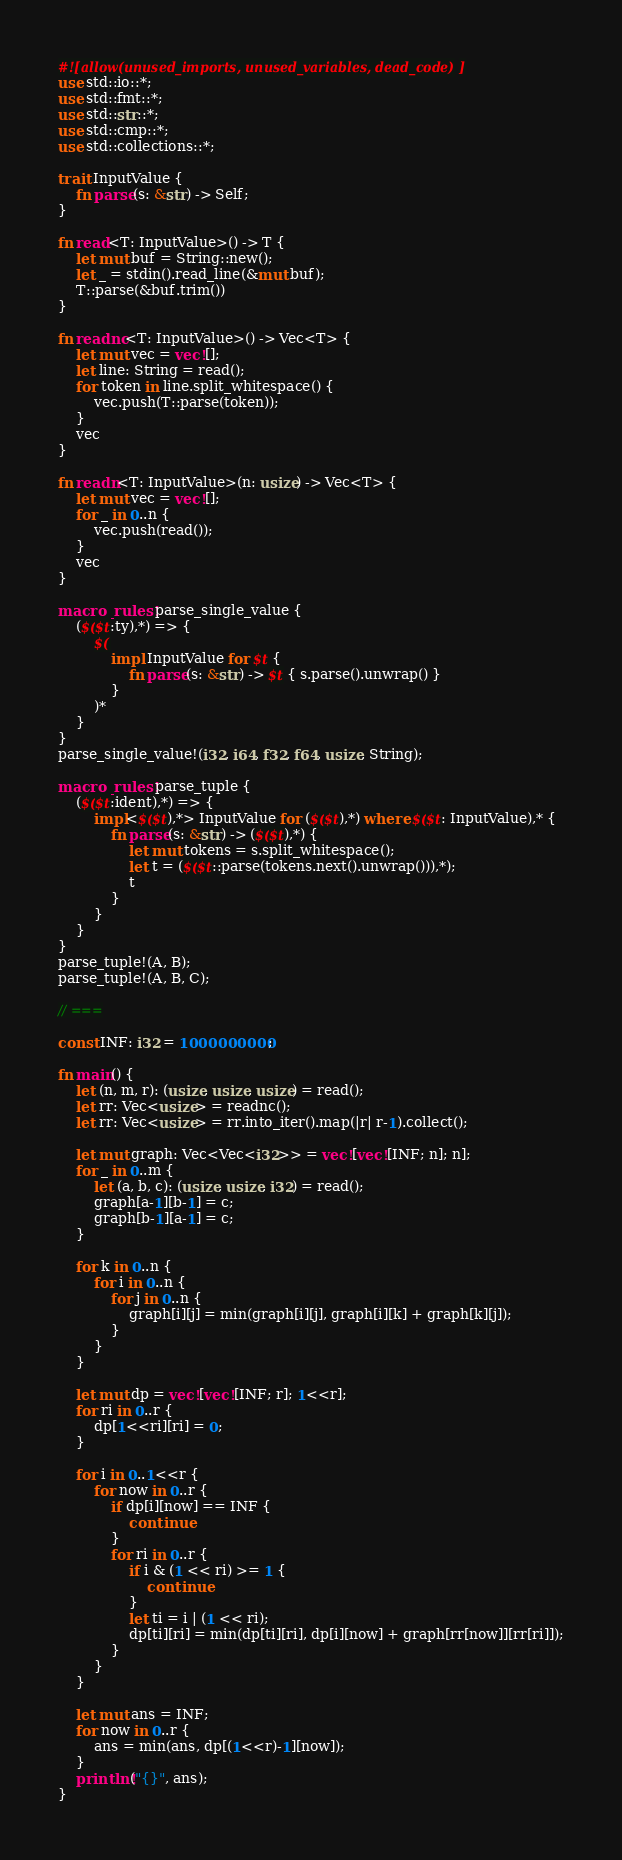Convert code to text. <code><loc_0><loc_0><loc_500><loc_500><_Rust_>#![allow(unused_imports, unused_variables, dead_code)]
use std::io::*;
use std::fmt::*;
use std::str::*;
use std::cmp::*;
use std::collections::*;

trait InputValue {
    fn parse(s: &str) -> Self;
}

fn read<T: InputValue>() -> T {
    let mut buf = String::new();
    let _ = stdin().read_line(&mut buf);
    T::parse(&buf.trim())
}

fn readnc<T: InputValue>() -> Vec<T> {
    let mut vec = vec![];
    let line: String = read();
    for token in line.split_whitespace() {
        vec.push(T::parse(token));
    }
    vec
}

fn readn<T: InputValue>(n: usize) -> Vec<T> {
    let mut vec = vec![];
    for _ in 0..n {
        vec.push(read());
    }
    vec
}

macro_rules! parse_single_value {
    ($($t:ty),*) => {
        $(
            impl InputValue for $t {
                fn parse(s: &str) -> $t { s.parse().unwrap() }
            }
        )*
	}
}
parse_single_value!(i32, i64, f32, f64, usize, String);

macro_rules! parse_tuple {
	($($t:ident),*) => {
		impl<$($t),*> InputValue for ($($t),*) where $($t: InputValue),* {
			fn parse(s: &str) -> ($($t),*) {
				let mut tokens = s.split_whitespace();
				let t = ($($t::parse(tokens.next().unwrap())),*);
				t
			}
		}
	}
}
parse_tuple!(A, B);
parse_tuple!(A, B, C);

// ===

const INF: i32 = 1000000000;

fn main() {
    let (n, m, r): (usize, usize, usize) = read();
    let rr: Vec<usize> = readnc();
    let rr: Vec<usize> = rr.into_iter().map(|r| r-1).collect();

    let mut graph: Vec<Vec<i32>> = vec![vec![INF; n]; n];
    for _ in 0..m {
        let (a, b, c): (usize, usize, i32) = read();
        graph[a-1][b-1] = c;
        graph[b-1][a-1] = c;
    }

    for k in 0..n {
        for i in 0..n {
            for j in 0..n {
                graph[i][j] = min(graph[i][j], graph[i][k] + graph[k][j]);
            }
        }
    }

    let mut dp = vec![vec![INF; r]; 1<<r];
    for ri in 0..r {
        dp[1<<ri][ri] = 0;
    }

    for i in 0..1<<r {
        for now in 0..r {
            if dp[i][now] == INF {
                continue
            }
            for ri in 0..r {
                if i & (1 << ri) >= 1 {
                    continue
                }
                let ti = i | (1 << ri);
                dp[ti][ri] = min(dp[ti][ri], dp[i][now] + graph[rr[now]][rr[ri]]);
            }
        }
    }

    let mut ans = INF;
    for now in 0..r {
        ans = min(ans, dp[(1<<r)-1][now]);
    }
    println!("{}", ans);
}</code> 